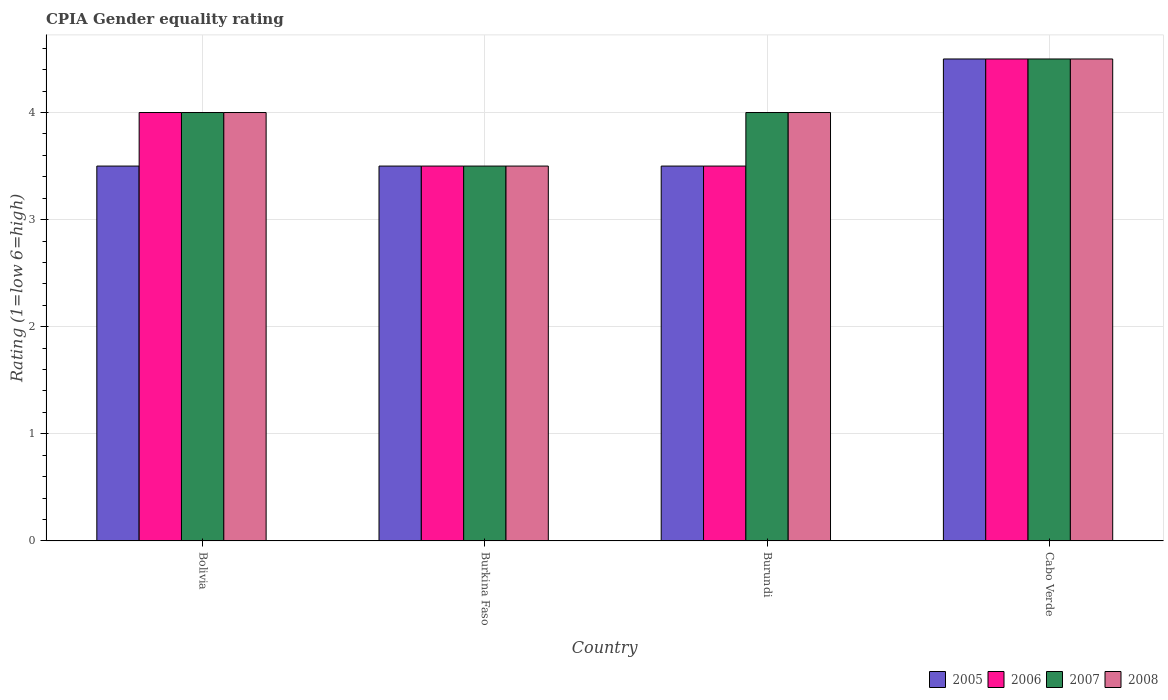How many different coloured bars are there?
Give a very brief answer. 4. How many bars are there on the 3rd tick from the left?
Give a very brief answer. 4. How many bars are there on the 4th tick from the right?
Provide a short and direct response. 4. What is the label of the 4th group of bars from the left?
Offer a terse response. Cabo Verde. In how many cases, is the number of bars for a given country not equal to the number of legend labels?
Provide a short and direct response. 0. Across all countries, what is the maximum CPIA rating in 2006?
Ensure brevity in your answer.  4.5. In which country was the CPIA rating in 2005 maximum?
Offer a very short reply. Cabo Verde. In which country was the CPIA rating in 2005 minimum?
Make the answer very short. Bolivia. What is the total CPIA rating in 2008 in the graph?
Make the answer very short. 16. What is the difference between the CPIA rating in 2007 in Burkina Faso and that in Cabo Verde?
Provide a succinct answer. -1. What is the difference between the CPIA rating in 2007 in Burkina Faso and the CPIA rating in 2006 in Bolivia?
Keep it short and to the point. -0.5. What is the average CPIA rating in 2005 per country?
Give a very brief answer. 3.75. What is the ratio of the CPIA rating in 2006 in Burundi to that in Cabo Verde?
Offer a terse response. 0.78. Is the CPIA rating in 2007 in Bolivia less than that in Burundi?
Your response must be concise. No. In how many countries, is the CPIA rating in 2007 greater than the average CPIA rating in 2007 taken over all countries?
Provide a short and direct response. 1. What does the 2nd bar from the right in Burundi represents?
Keep it short and to the point. 2007. Is it the case that in every country, the sum of the CPIA rating in 2008 and CPIA rating in 2007 is greater than the CPIA rating in 2006?
Provide a succinct answer. Yes. What is the difference between two consecutive major ticks on the Y-axis?
Provide a short and direct response. 1. Does the graph contain any zero values?
Ensure brevity in your answer.  No. Where does the legend appear in the graph?
Your answer should be compact. Bottom right. What is the title of the graph?
Keep it short and to the point. CPIA Gender equality rating. Does "1989" appear as one of the legend labels in the graph?
Offer a very short reply. No. What is the label or title of the Y-axis?
Provide a succinct answer. Rating (1=low 6=high). What is the Rating (1=low 6=high) in 2006 in Bolivia?
Offer a terse response. 4. What is the Rating (1=low 6=high) of 2007 in Bolivia?
Offer a terse response. 4. What is the Rating (1=low 6=high) in 2008 in Bolivia?
Give a very brief answer. 4. What is the Rating (1=low 6=high) of 2006 in Burkina Faso?
Give a very brief answer. 3.5. What is the Rating (1=low 6=high) of 2007 in Burkina Faso?
Provide a succinct answer. 3.5. What is the Rating (1=low 6=high) in 2005 in Burundi?
Make the answer very short. 3.5. What is the Rating (1=low 6=high) in 2006 in Burundi?
Your answer should be very brief. 3.5. What is the Rating (1=low 6=high) of 2008 in Burundi?
Make the answer very short. 4. What is the Rating (1=low 6=high) of 2005 in Cabo Verde?
Offer a terse response. 4.5. What is the Rating (1=low 6=high) in 2007 in Cabo Verde?
Give a very brief answer. 4.5. What is the Rating (1=low 6=high) in 2008 in Cabo Verde?
Ensure brevity in your answer.  4.5. Across all countries, what is the maximum Rating (1=low 6=high) of 2005?
Provide a short and direct response. 4.5. Across all countries, what is the maximum Rating (1=low 6=high) of 2007?
Your answer should be compact. 4.5. Across all countries, what is the maximum Rating (1=low 6=high) in 2008?
Make the answer very short. 4.5. Across all countries, what is the minimum Rating (1=low 6=high) of 2005?
Your answer should be compact. 3.5. Across all countries, what is the minimum Rating (1=low 6=high) of 2006?
Your answer should be compact. 3.5. Across all countries, what is the minimum Rating (1=low 6=high) of 2008?
Provide a succinct answer. 3.5. What is the difference between the Rating (1=low 6=high) of 2007 in Bolivia and that in Burkina Faso?
Keep it short and to the point. 0.5. What is the difference between the Rating (1=low 6=high) in 2008 in Bolivia and that in Burkina Faso?
Make the answer very short. 0.5. What is the difference between the Rating (1=low 6=high) of 2005 in Bolivia and that in Burundi?
Your answer should be compact. 0. What is the difference between the Rating (1=low 6=high) of 2005 in Bolivia and that in Cabo Verde?
Provide a succinct answer. -1. What is the difference between the Rating (1=low 6=high) in 2006 in Bolivia and that in Cabo Verde?
Offer a very short reply. -0.5. What is the difference between the Rating (1=low 6=high) of 2006 in Burkina Faso and that in Burundi?
Ensure brevity in your answer.  0. What is the difference between the Rating (1=low 6=high) in 2007 in Burkina Faso and that in Burundi?
Provide a short and direct response. -0.5. What is the difference between the Rating (1=low 6=high) of 2005 in Burkina Faso and that in Cabo Verde?
Offer a terse response. -1. What is the difference between the Rating (1=low 6=high) in 2006 in Burkina Faso and that in Cabo Verde?
Give a very brief answer. -1. What is the difference between the Rating (1=low 6=high) in 2008 in Burkina Faso and that in Cabo Verde?
Provide a succinct answer. -1. What is the difference between the Rating (1=low 6=high) of 2007 in Burundi and that in Cabo Verde?
Your response must be concise. -0.5. What is the difference between the Rating (1=low 6=high) of 2005 in Bolivia and the Rating (1=low 6=high) of 2007 in Burkina Faso?
Provide a short and direct response. 0. What is the difference between the Rating (1=low 6=high) of 2007 in Bolivia and the Rating (1=low 6=high) of 2008 in Burkina Faso?
Your answer should be very brief. 0.5. What is the difference between the Rating (1=low 6=high) of 2005 in Bolivia and the Rating (1=low 6=high) of 2008 in Burundi?
Your answer should be compact. -0.5. What is the difference between the Rating (1=low 6=high) in 2006 in Bolivia and the Rating (1=low 6=high) in 2008 in Burundi?
Give a very brief answer. 0. What is the difference between the Rating (1=low 6=high) of 2007 in Bolivia and the Rating (1=low 6=high) of 2008 in Burundi?
Provide a short and direct response. 0. What is the difference between the Rating (1=low 6=high) in 2005 in Bolivia and the Rating (1=low 6=high) in 2006 in Cabo Verde?
Keep it short and to the point. -1. What is the difference between the Rating (1=low 6=high) of 2006 in Bolivia and the Rating (1=low 6=high) of 2007 in Cabo Verde?
Provide a short and direct response. -0.5. What is the difference between the Rating (1=low 6=high) in 2006 in Bolivia and the Rating (1=low 6=high) in 2008 in Cabo Verde?
Provide a succinct answer. -0.5. What is the difference between the Rating (1=low 6=high) of 2007 in Bolivia and the Rating (1=low 6=high) of 2008 in Cabo Verde?
Make the answer very short. -0.5. What is the difference between the Rating (1=low 6=high) of 2005 in Burkina Faso and the Rating (1=low 6=high) of 2006 in Burundi?
Give a very brief answer. 0. What is the difference between the Rating (1=low 6=high) in 2006 in Burkina Faso and the Rating (1=low 6=high) in 2007 in Burundi?
Provide a short and direct response. -0.5. What is the difference between the Rating (1=low 6=high) in 2005 in Burkina Faso and the Rating (1=low 6=high) in 2008 in Cabo Verde?
Your answer should be compact. -1. What is the difference between the Rating (1=low 6=high) in 2007 in Burkina Faso and the Rating (1=low 6=high) in 2008 in Cabo Verde?
Keep it short and to the point. -1. What is the difference between the Rating (1=low 6=high) in 2005 in Burundi and the Rating (1=low 6=high) in 2007 in Cabo Verde?
Provide a succinct answer. -1. What is the difference between the Rating (1=low 6=high) in 2005 in Burundi and the Rating (1=low 6=high) in 2008 in Cabo Verde?
Make the answer very short. -1. What is the difference between the Rating (1=low 6=high) in 2006 in Burundi and the Rating (1=low 6=high) in 2007 in Cabo Verde?
Make the answer very short. -1. What is the difference between the Rating (1=low 6=high) of 2006 in Burundi and the Rating (1=low 6=high) of 2008 in Cabo Verde?
Provide a succinct answer. -1. What is the difference between the Rating (1=low 6=high) of 2007 in Burundi and the Rating (1=low 6=high) of 2008 in Cabo Verde?
Offer a very short reply. -0.5. What is the average Rating (1=low 6=high) in 2005 per country?
Keep it short and to the point. 3.75. What is the average Rating (1=low 6=high) in 2006 per country?
Your answer should be compact. 3.88. What is the average Rating (1=low 6=high) of 2007 per country?
Provide a short and direct response. 4. What is the difference between the Rating (1=low 6=high) of 2005 and Rating (1=low 6=high) of 2008 in Bolivia?
Offer a very short reply. -0.5. What is the difference between the Rating (1=low 6=high) in 2006 and Rating (1=low 6=high) in 2007 in Bolivia?
Provide a short and direct response. 0. What is the difference between the Rating (1=low 6=high) in 2006 and Rating (1=low 6=high) in 2008 in Bolivia?
Your answer should be very brief. 0. What is the difference between the Rating (1=low 6=high) of 2005 and Rating (1=low 6=high) of 2006 in Burkina Faso?
Your response must be concise. 0. What is the difference between the Rating (1=low 6=high) of 2005 and Rating (1=low 6=high) of 2007 in Burkina Faso?
Offer a very short reply. 0. What is the difference between the Rating (1=low 6=high) of 2005 and Rating (1=low 6=high) of 2008 in Burundi?
Your answer should be compact. -0.5. What is the difference between the Rating (1=low 6=high) of 2006 and Rating (1=low 6=high) of 2007 in Burundi?
Provide a succinct answer. -0.5. What is the difference between the Rating (1=low 6=high) of 2006 and Rating (1=low 6=high) of 2008 in Burundi?
Offer a terse response. -0.5. What is the difference between the Rating (1=low 6=high) in 2007 and Rating (1=low 6=high) in 2008 in Burundi?
Offer a very short reply. 0. What is the difference between the Rating (1=low 6=high) of 2005 and Rating (1=low 6=high) of 2006 in Cabo Verde?
Keep it short and to the point. 0. What is the difference between the Rating (1=low 6=high) in 2005 and Rating (1=low 6=high) in 2007 in Cabo Verde?
Keep it short and to the point. 0. What is the difference between the Rating (1=low 6=high) of 2006 and Rating (1=low 6=high) of 2007 in Cabo Verde?
Your answer should be very brief. 0. What is the difference between the Rating (1=low 6=high) of 2006 and Rating (1=low 6=high) of 2008 in Cabo Verde?
Offer a very short reply. 0. What is the ratio of the Rating (1=low 6=high) in 2005 in Bolivia to that in Burkina Faso?
Your answer should be compact. 1. What is the ratio of the Rating (1=low 6=high) of 2007 in Bolivia to that in Burkina Faso?
Provide a short and direct response. 1.14. What is the ratio of the Rating (1=low 6=high) of 2005 in Bolivia to that in Burundi?
Your answer should be compact. 1. What is the ratio of the Rating (1=low 6=high) of 2006 in Bolivia to that in Burundi?
Your answer should be compact. 1.14. What is the ratio of the Rating (1=low 6=high) in 2007 in Bolivia to that in Burundi?
Offer a very short reply. 1. What is the ratio of the Rating (1=low 6=high) of 2008 in Bolivia to that in Burundi?
Give a very brief answer. 1. What is the ratio of the Rating (1=low 6=high) of 2007 in Bolivia to that in Cabo Verde?
Give a very brief answer. 0.89. What is the ratio of the Rating (1=low 6=high) in 2005 in Burkina Faso to that in Burundi?
Make the answer very short. 1. What is the ratio of the Rating (1=low 6=high) in 2006 in Burkina Faso to that in Burundi?
Ensure brevity in your answer.  1. What is the ratio of the Rating (1=low 6=high) in 2007 in Burkina Faso to that in Burundi?
Provide a short and direct response. 0.88. What is the ratio of the Rating (1=low 6=high) of 2008 in Burkina Faso to that in Burundi?
Provide a succinct answer. 0.88. What is the ratio of the Rating (1=low 6=high) in 2005 in Burkina Faso to that in Cabo Verde?
Offer a terse response. 0.78. What is the ratio of the Rating (1=low 6=high) in 2006 in Burkina Faso to that in Cabo Verde?
Your answer should be compact. 0.78. What is the ratio of the Rating (1=low 6=high) of 2007 in Burkina Faso to that in Cabo Verde?
Offer a terse response. 0.78. What is the ratio of the Rating (1=low 6=high) in 2005 in Burundi to that in Cabo Verde?
Offer a terse response. 0.78. What is the ratio of the Rating (1=low 6=high) in 2006 in Burundi to that in Cabo Verde?
Make the answer very short. 0.78. What is the ratio of the Rating (1=low 6=high) in 2008 in Burundi to that in Cabo Verde?
Ensure brevity in your answer.  0.89. What is the difference between the highest and the second highest Rating (1=low 6=high) of 2006?
Your response must be concise. 0.5. What is the difference between the highest and the second highest Rating (1=low 6=high) of 2007?
Provide a short and direct response. 0.5. What is the difference between the highest and the lowest Rating (1=low 6=high) in 2008?
Make the answer very short. 1. 